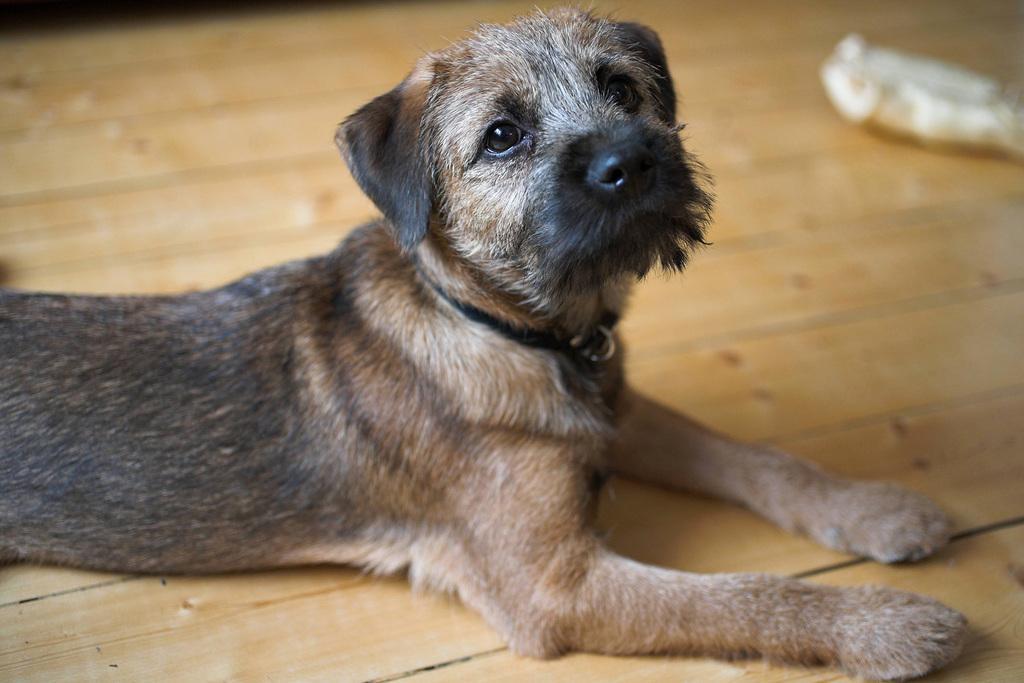Could you give a brief overview of what you see in this image? In the image there is a dog lying on the wooden floor. 